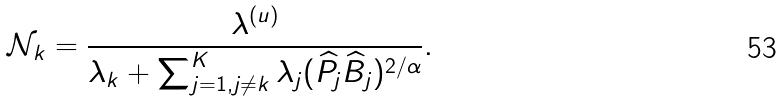Convert formula to latex. <formula><loc_0><loc_0><loc_500><loc_500>\mathcal { N } _ { k } = \frac { \lambda ^ { ( u ) } } { \lambda _ { k } + \sum _ { j = 1 , j \neq k } ^ { K } \lambda _ { j } ( \widehat { P } _ { j } \widehat { B } _ { j } ) ^ { 2 / \alpha } } .</formula> 